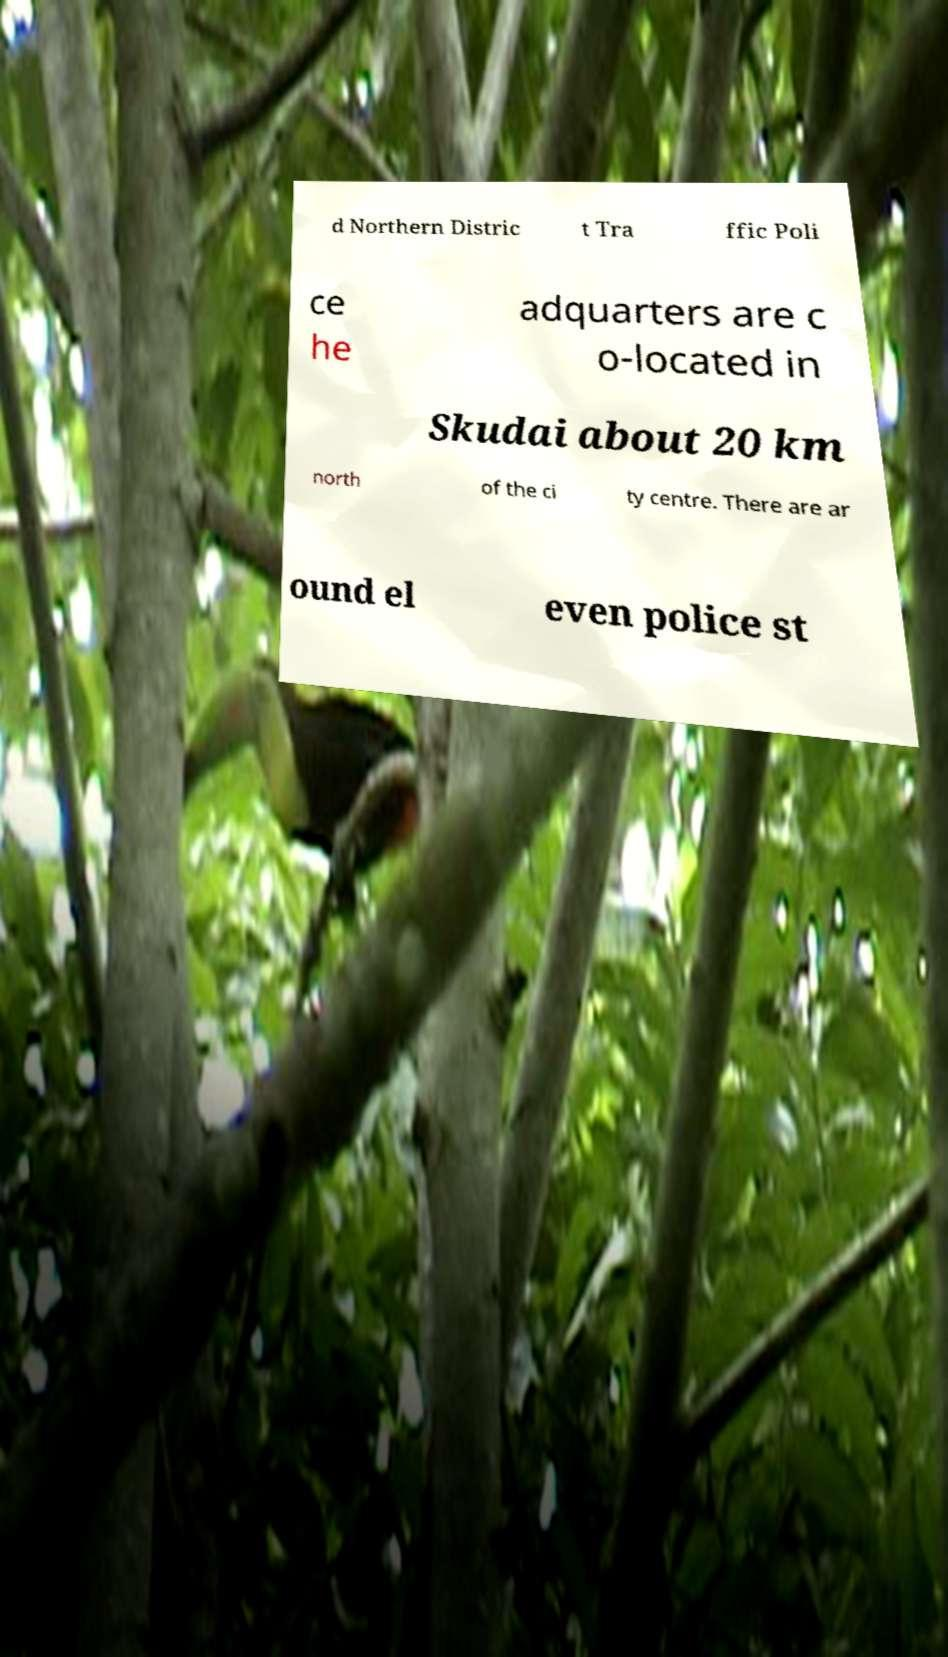Please identify and transcribe the text found in this image. d Northern Distric t Tra ffic Poli ce he adquarters are c o-located in Skudai about 20 km north of the ci ty centre. There are ar ound el even police st 